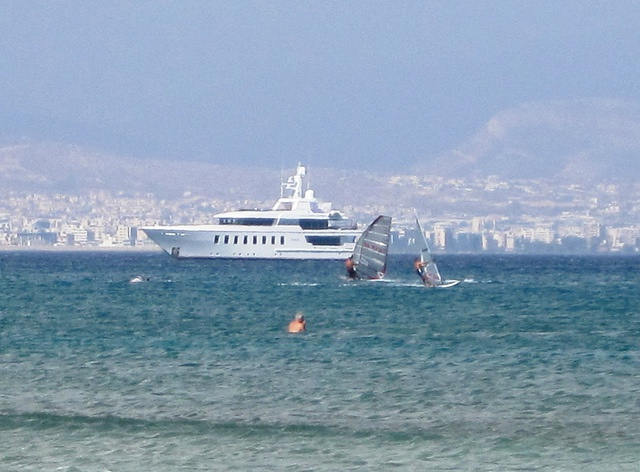Describe the objects in this image and their specific colors. I can see boat in lightblue, lightgray, darkgray, and gray tones, people in lightblue, tan, gray, and darkgray tones, people in lightblue, gray, darkgray, and navy tones, and people in lightblue, black, and gray tones in this image. 